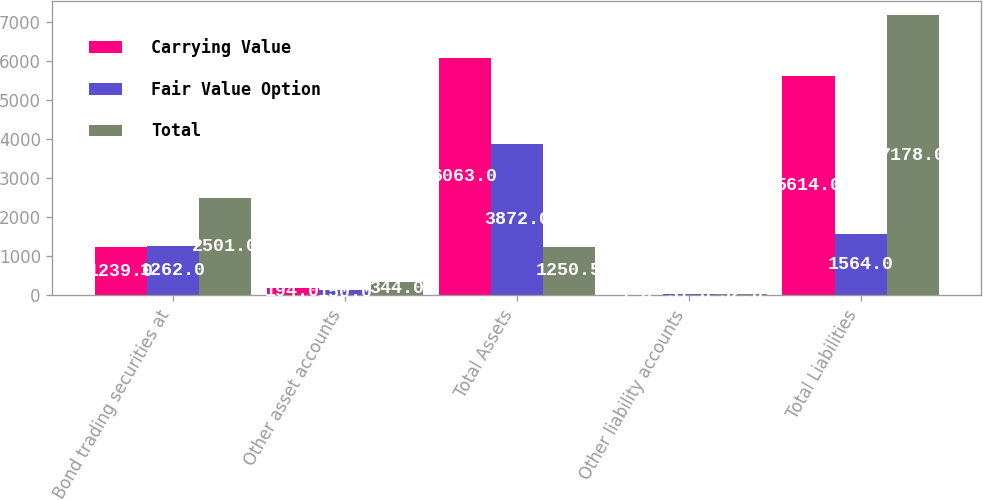Convert chart. <chart><loc_0><loc_0><loc_500><loc_500><stacked_bar_chart><ecel><fcel>Bond trading securities at<fcel>Other asset accounts<fcel>Total Assets<fcel>Other liability accounts<fcel>Total Liabilities<nl><fcel>Carrying Value<fcel>1239<fcel>194<fcel>6063<fcel>1<fcel>5614<nl><fcel>Fair Value Option<fcel>1262<fcel>150<fcel>3872<fcel>31<fcel>1564<nl><fcel>Total<fcel>2501<fcel>344<fcel>1250.5<fcel>32<fcel>7178<nl></chart> 